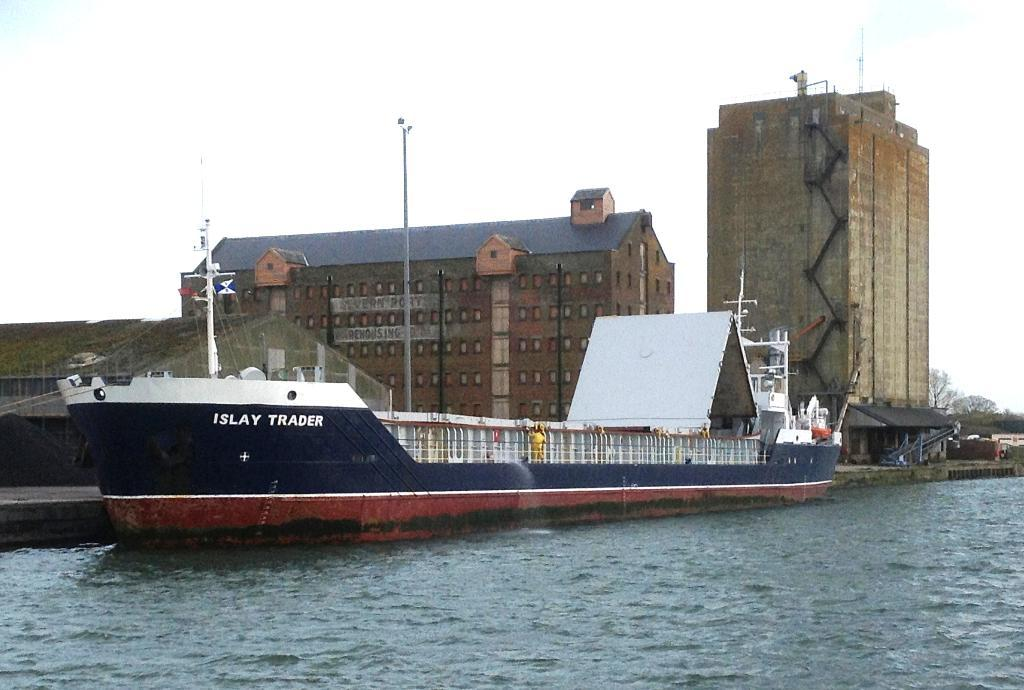What is the main subject in the middle of the image? There is a ship in the water in the middle of the image. What else can be seen in the image besides the ship? There are buildings visible in the image. What type of vegetation is on the right side of the image? There are trees on the right side of the image. What is visible at the top of the image? The sky is visible at the top of the image. What type of machine is being used to operate the ship in the image? There is no machine visible in the image; the ship is likely being operated by its crew or an automated system. How many seats are available for passengers on the ship in the image? There is no information about the number of seats or passengers on the ship in the image. 